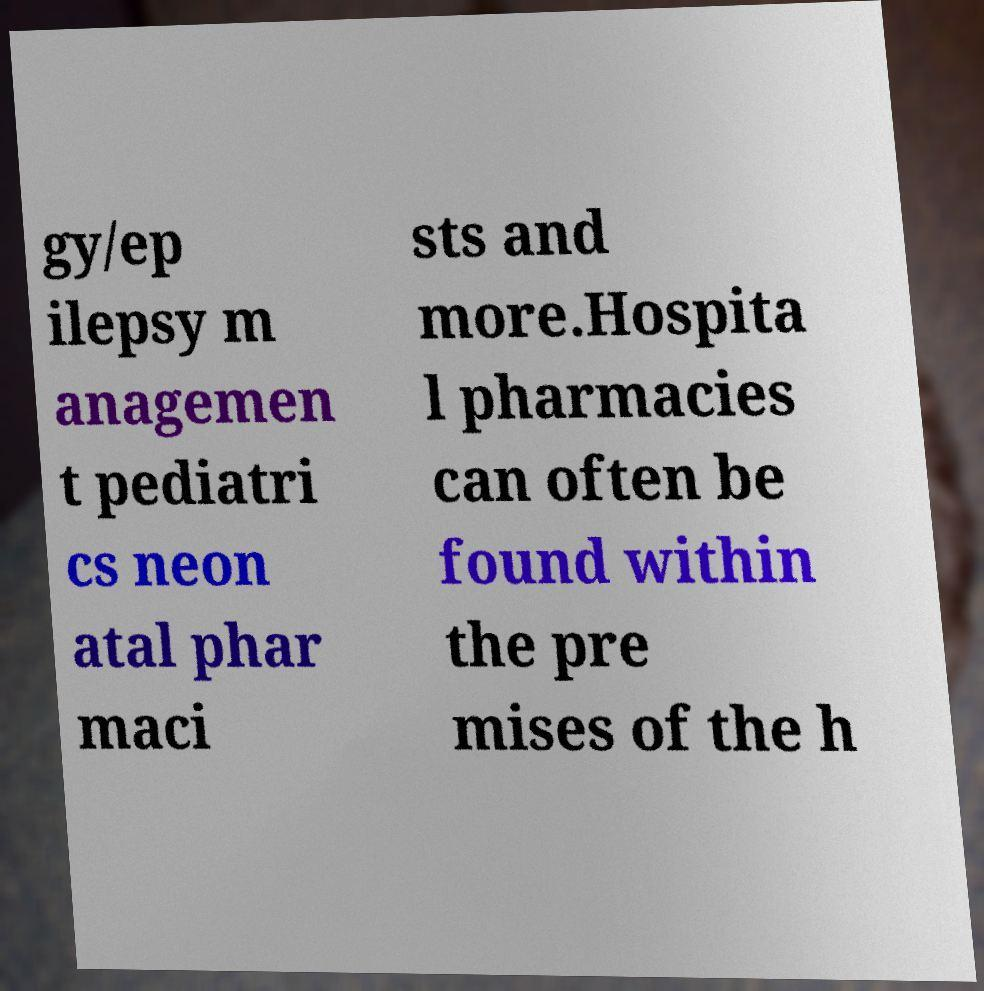For documentation purposes, I need the text within this image transcribed. Could you provide that? gy/ep ilepsy m anagemen t pediatri cs neon atal phar maci sts and more.Hospita l pharmacies can often be found within the pre mises of the h 